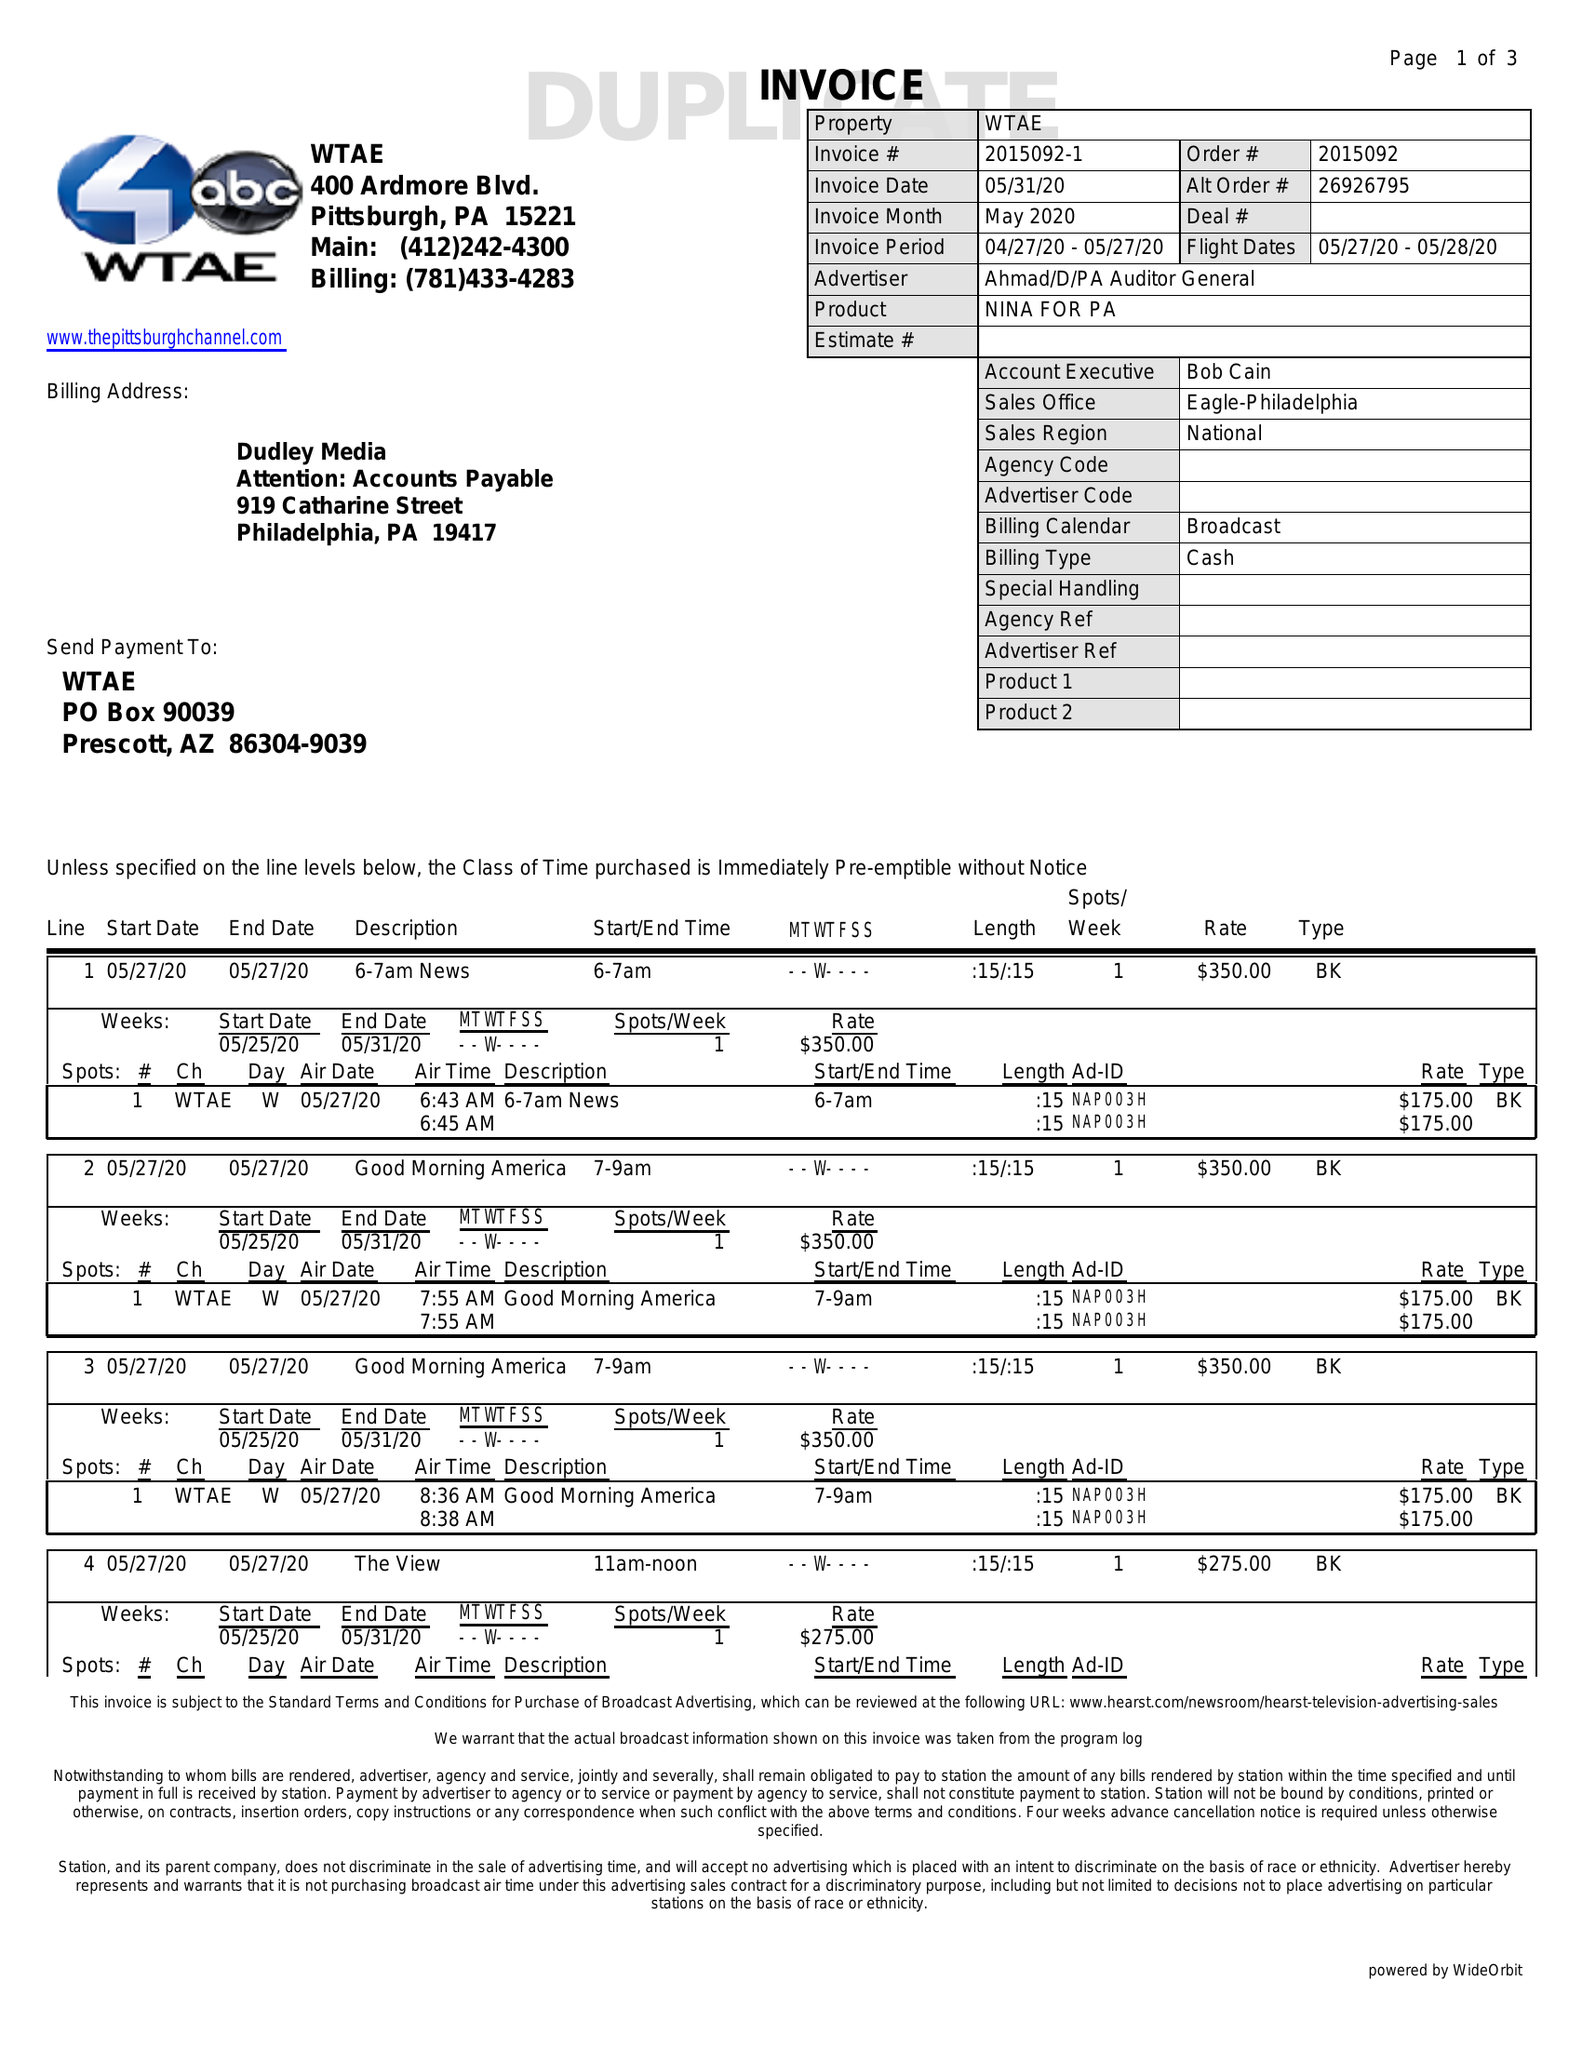What is the value for the advertiser?
Answer the question using a single word or phrase. AHMAD/D/PAAUDITORGENERAL 